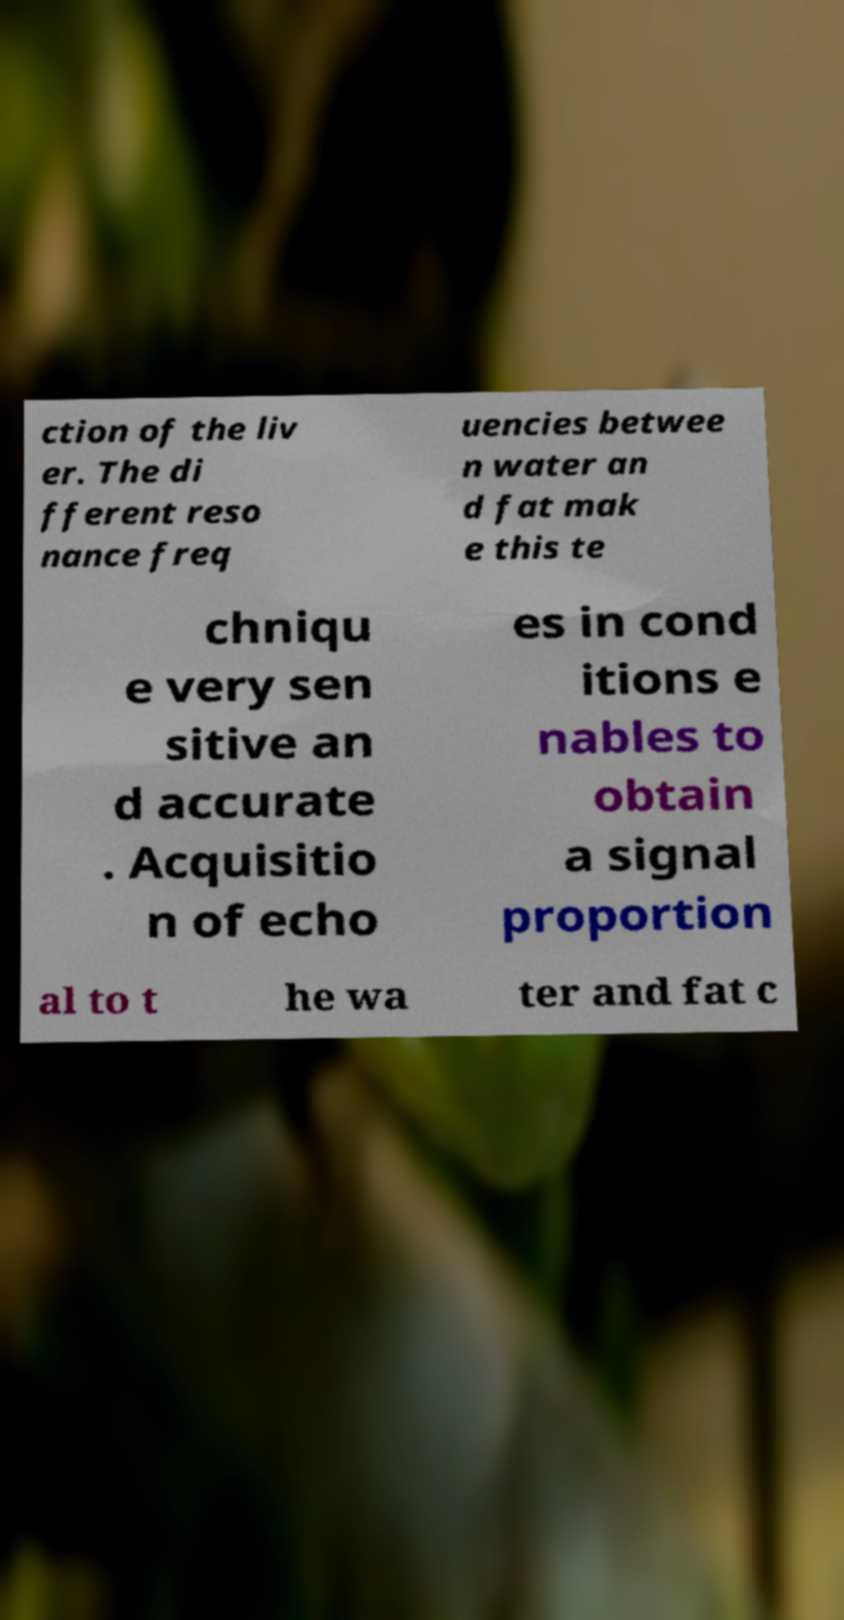Please identify and transcribe the text found in this image. ction of the liv er. The di fferent reso nance freq uencies betwee n water an d fat mak e this te chniqu e very sen sitive an d accurate . Acquisitio n of echo es in cond itions e nables to obtain a signal proportion al to t he wa ter and fat c 